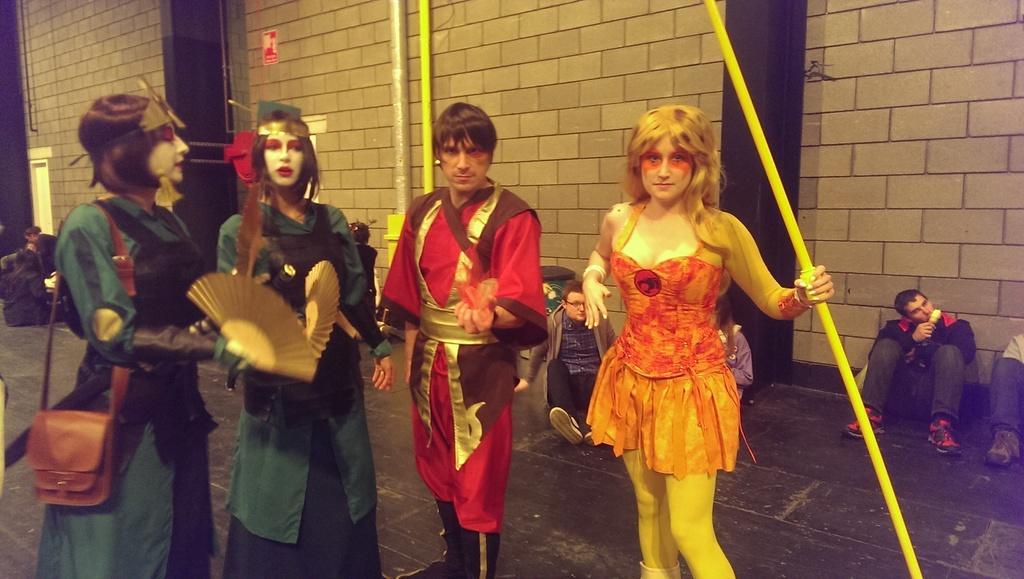In one or two sentences, can you explain what this image depicts? In this image I can see people among them some are sitting and some are standing. These people in the front are wearing costumes and holding some objects. In the background I can see pips, a wall and other objects on the ground. 